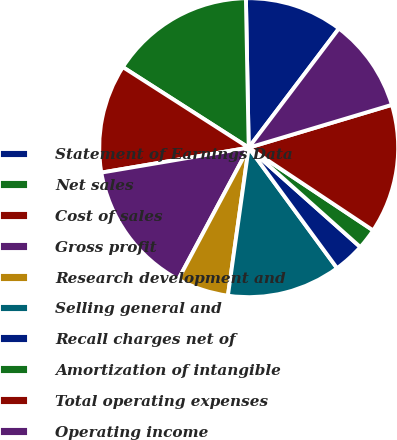Convert chart. <chart><loc_0><loc_0><loc_500><loc_500><pie_chart><fcel>Statement of Earnings Data<fcel>Net sales<fcel>Cost of sales<fcel>Gross profit<fcel>Research development and<fcel>Selling general and<fcel>Recall charges net of<fcel>Amortization of intangible<fcel>Total operating expenses<fcel>Operating income<nl><fcel>10.61%<fcel>15.64%<fcel>11.73%<fcel>14.52%<fcel>5.59%<fcel>12.29%<fcel>3.35%<fcel>2.24%<fcel>13.97%<fcel>10.06%<nl></chart> 